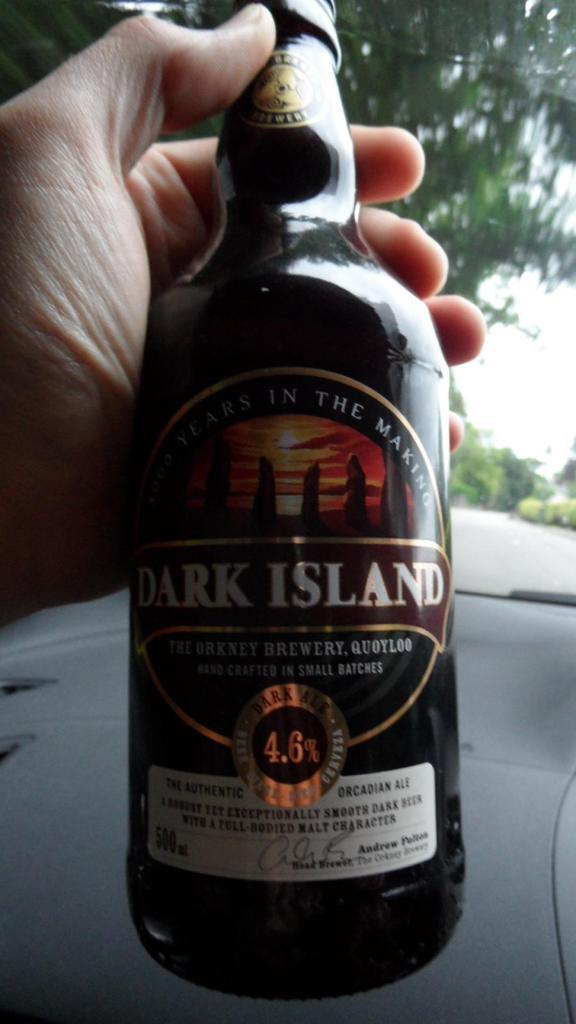<image>
Provide a brief description of the given image. A person holding a Dark Island brand beer in their hand 